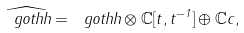Convert formula to latex. <formula><loc_0><loc_0><loc_500><loc_500>\widehat { \ g o t h { h } } = \ g o t h { h } \otimes \mathbb { C } [ t , t ^ { - 1 } ] \oplus \mathbb { C } c ,</formula> 